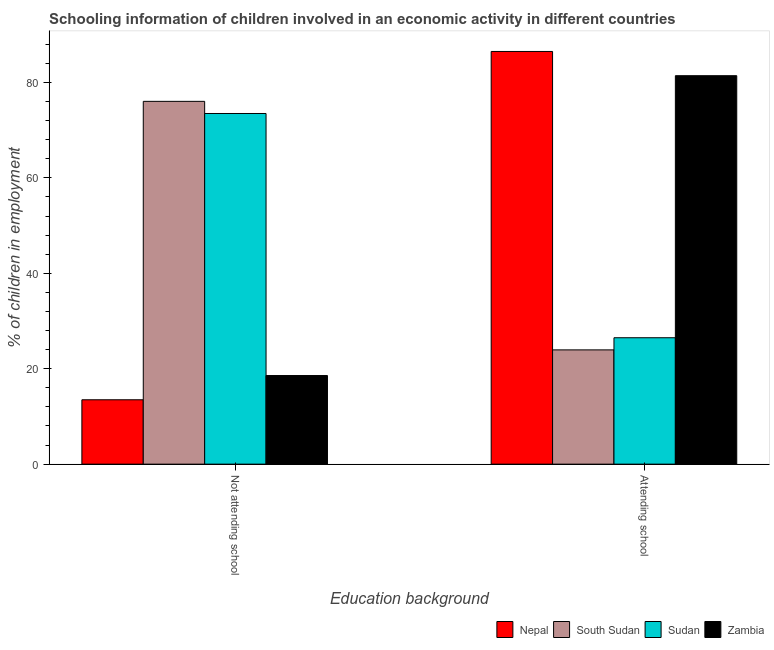Are the number of bars per tick equal to the number of legend labels?
Your answer should be compact. Yes. How many bars are there on the 1st tick from the left?
Offer a terse response. 4. How many bars are there on the 2nd tick from the right?
Provide a succinct answer. 4. What is the label of the 1st group of bars from the left?
Offer a very short reply. Not attending school. What is the percentage of employed children who are not attending school in Zambia?
Your response must be concise. 18.58. Across all countries, what is the maximum percentage of employed children who are attending school?
Your response must be concise. 86.51. Across all countries, what is the minimum percentage of employed children who are not attending school?
Your answer should be very brief. 13.49. In which country was the percentage of employed children who are not attending school maximum?
Ensure brevity in your answer.  South Sudan. In which country was the percentage of employed children who are not attending school minimum?
Provide a short and direct response. Nepal. What is the total percentage of employed children who are not attending school in the graph?
Offer a terse response. 181.62. What is the difference between the percentage of employed children who are attending school in Nepal and that in Zambia?
Make the answer very short. 5.08. What is the difference between the percentage of employed children who are attending school in Nepal and the percentage of employed children who are not attending school in Zambia?
Ensure brevity in your answer.  67.93. What is the average percentage of employed children who are attending school per country?
Offer a very short reply. 54.6. What is the difference between the percentage of employed children who are not attending school and percentage of employed children who are attending school in South Sudan?
Give a very brief answer. 52.1. What is the ratio of the percentage of employed children who are not attending school in South Sudan to that in Nepal?
Offer a very short reply. 5.64. Is the percentage of employed children who are not attending school in Sudan less than that in Zambia?
Provide a short and direct response. No. In how many countries, is the percentage of employed children who are not attending school greater than the average percentage of employed children who are not attending school taken over all countries?
Your answer should be very brief. 2. What does the 2nd bar from the left in Attending school represents?
Ensure brevity in your answer.  South Sudan. What does the 2nd bar from the right in Not attending school represents?
Your answer should be very brief. Sudan. Are all the bars in the graph horizontal?
Offer a terse response. No. How many countries are there in the graph?
Your answer should be very brief. 4. Where does the legend appear in the graph?
Your response must be concise. Bottom right. How many legend labels are there?
Your answer should be very brief. 4. How are the legend labels stacked?
Keep it short and to the point. Horizontal. What is the title of the graph?
Provide a short and direct response. Schooling information of children involved in an economic activity in different countries. What is the label or title of the X-axis?
Your response must be concise. Education background. What is the label or title of the Y-axis?
Ensure brevity in your answer.  % of children in employment. What is the % of children in employment in Nepal in Not attending school?
Ensure brevity in your answer.  13.49. What is the % of children in employment in South Sudan in Not attending school?
Your response must be concise. 76.05. What is the % of children in employment in Sudan in Not attending school?
Provide a succinct answer. 73.5. What is the % of children in employment in Zambia in Not attending school?
Give a very brief answer. 18.58. What is the % of children in employment in Nepal in Attending school?
Offer a terse response. 86.51. What is the % of children in employment in South Sudan in Attending school?
Give a very brief answer. 23.95. What is the % of children in employment in Sudan in Attending school?
Give a very brief answer. 26.5. What is the % of children in employment of Zambia in Attending school?
Give a very brief answer. 81.42. Across all Education background, what is the maximum % of children in employment in Nepal?
Your answer should be very brief. 86.51. Across all Education background, what is the maximum % of children in employment in South Sudan?
Your answer should be very brief. 76.05. Across all Education background, what is the maximum % of children in employment of Sudan?
Provide a succinct answer. 73.5. Across all Education background, what is the maximum % of children in employment of Zambia?
Keep it short and to the point. 81.42. Across all Education background, what is the minimum % of children in employment in Nepal?
Ensure brevity in your answer.  13.49. Across all Education background, what is the minimum % of children in employment of South Sudan?
Give a very brief answer. 23.95. Across all Education background, what is the minimum % of children in employment of Sudan?
Keep it short and to the point. 26.5. Across all Education background, what is the minimum % of children in employment of Zambia?
Give a very brief answer. 18.58. What is the total % of children in employment in Nepal in the graph?
Keep it short and to the point. 100. What is the total % of children in employment in South Sudan in the graph?
Ensure brevity in your answer.  100. What is the total % of children in employment in Sudan in the graph?
Keep it short and to the point. 100. What is the difference between the % of children in employment of Nepal in Not attending school and that in Attending school?
Keep it short and to the point. -73.01. What is the difference between the % of children in employment in South Sudan in Not attending school and that in Attending school?
Provide a short and direct response. 52.1. What is the difference between the % of children in employment of Sudan in Not attending school and that in Attending school?
Provide a succinct answer. 47. What is the difference between the % of children in employment in Zambia in Not attending school and that in Attending school?
Keep it short and to the point. -62.85. What is the difference between the % of children in employment in Nepal in Not attending school and the % of children in employment in South Sudan in Attending school?
Provide a short and direct response. -10.46. What is the difference between the % of children in employment in Nepal in Not attending school and the % of children in employment in Sudan in Attending school?
Ensure brevity in your answer.  -13. What is the difference between the % of children in employment in Nepal in Not attending school and the % of children in employment in Zambia in Attending school?
Keep it short and to the point. -67.93. What is the difference between the % of children in employment of South Sudan in Not attending school and the % of children in employment of Sudan in Attending school?
Your response must be concise. 49.55. What is the difference between the % of children in employment in South Sudan in Not attending school and the % of children in employment in Zambia in Attending school?
Offer a terse response. -5.38. What is the difference between the % of children in employment of Sudan in Not attending school and the % of children in employment of Zambia in Attending school?
Provide a succinct answer. -7.92. What is the average % of children in employment in Nepal per Education background?
Offer a terse response. 50. What is the average % of children in employment in Sudan per Education background?
Make the answer very short. 50. What is the difference between the % of children in employment of Nepal and % of children in employment of South Sudan in Not attending school?
Make the answer very short. -62.55. What is the difference between the % of children in employment in Nepal and % of children in employment in Sudan in Not attending school?
Ensure brevity in your answer.  -60.01. What is the difference between the % of children in employment in Nepal and % of children in employment in Zambia in Not attending school?
Provide a short and direct response. -5.08. What is the difference between the % of children in employment in South Sudan and % of children in employment in Sudan in Not attending school?
Your answer should be very brief. 2.55. What is the difference between the % of children in employment in South Sudan and % of children in employment in Zambia in Not attending school?
Make the answer very short. 57.47. What is the difference between the % of children in employment of Sudan and % of children in employment of Zambia in Not attending school?
Offer a very short reply. 54.93. What is the difference between the % of children in employment of Nepal and % of children in employment of South Sudan in Attending school?
Give a very brief answer. 62.55. What is the difference between the % of children in employment in Nepal and % of children in employment in Sudan in Attending school?
Ensure brevity in your answer.  60.01. What is the difference between the % of children in employment of Nepal and % of children in employment of Zambia in Attending school?
Offer a terse response. 5.08. What is the difference between the % of children in employment of South Sudan and % of children in employment of Sudan in Attending school?
Give a very brief answer. -2.55. What is the difference between the % of children in employment of South Sudan and % of children in employment of Zambia in Attending school?
Ensure brevity in your answer.  -57.47. What is the difference between the % of children in employment of Sudan and % of children in employment of Zambia in Attending school?
Your response must be concise. -54.93. What is the ratio of the % of children in employment of Nepal in Not attending school to that in Attending school?
Ensure brevity in your answer.  0.16. What is the ratio of the % of children in employment in South Sudan in Not attending school to that in Attending school?
Ensure brevity in your answer.  3.18. What is the ratio of the % of children in employment of Sudan in Not attending school to that in Attending school?
Offer a terse response. 2.77. What is the ratio of the % of children in employment in Zambia in Not attending school to that in Attending school?
Provide a short and direct response. 0.23. What is the difference between the highest and the second highest % of children in employment of Nepal?
Your answer should be compact. 73.01. What is the difference between the highest and the second highest % of children in employment in South Sudan?
Provide a short and direct response. 52.1. What is the difference between the highest and the second highest % of children in employment in Sudan?
Offer a terse response. 47. What is the difference between the highest and the second highest % of children in employment in Zambia?
Keep it short and to the point. 62.85. What is the difference between the highest and the lowest % of children in employment in Nepal?
Offer a terse response. 73.01. What is the difference between the highest and the lowest % of children in employment of South Sudan?
Make the answer very short. 52.1. What is the difference between the highest and the lowest % of children in employment in Sudan?
Keep it short and to the point. 47. What is the difference between the highest and the lowest % of children in employment of Zambia?
Offer a very short reply. 62.85. 